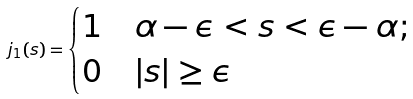Convert formula to latex. <formula><loc_0><loc_0><loc_500><loc_500>j _ { 1 } ( s ) = \begin{cases} 1 \quad \alpha - \epsilon < s < \epsilon - \alpha ; \\ 0 \quad | s | \geq \epsilon \end{cases}</formula> 